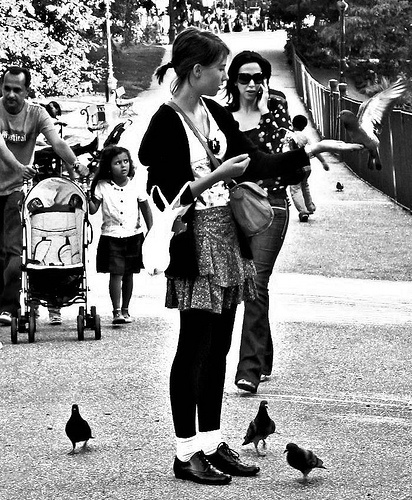Describe the objects in this image and their specific colors. I can see people in darkgray, black, white, and gray tones, people in darkgray, black, lightgray, and gray tones, people in darkgray, black, gray, and lightgray tones, people in darkgray, black, whitesmoke, and gray tones, and handbag in darkgray, white, black, and gray tones in this image. 